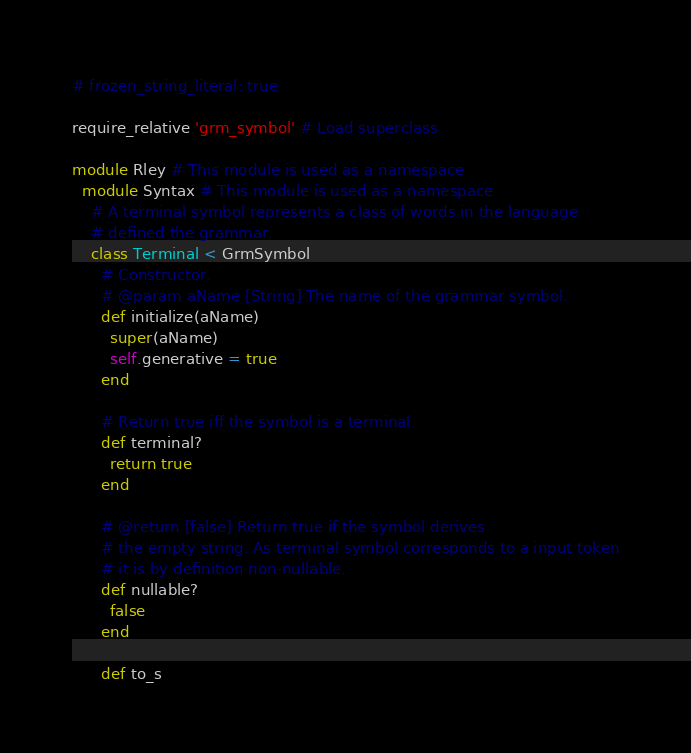<code> <loc_0><loc_0><loc_500><loc_500><_Ruby_># frozen_string_literal: true

require_relative 'grm_symbol' # Load superclass

module Rley # This module is used as a namespace
  module Syntax # This module is used as a namespace
    # A terminal symbol represents a class of words in the language
    # defined the grammar.
    class Terminal < GrmSymbol
      # Constructor.
      # @param aName [String] The name of the grammar symbol.
      def initialize(aName)
        super(aName)
        self.generative = true
      end

      # Return true iff the symbol is a terminal
      def terminal?
        return true
      end

      # @return [false] Return true if the symbol derives
      # the empty string. As terminal symbol corresponds to a input token
      # it is by definition non-nullable.
      def nullable?
        false
      end

      def to_s</code> 